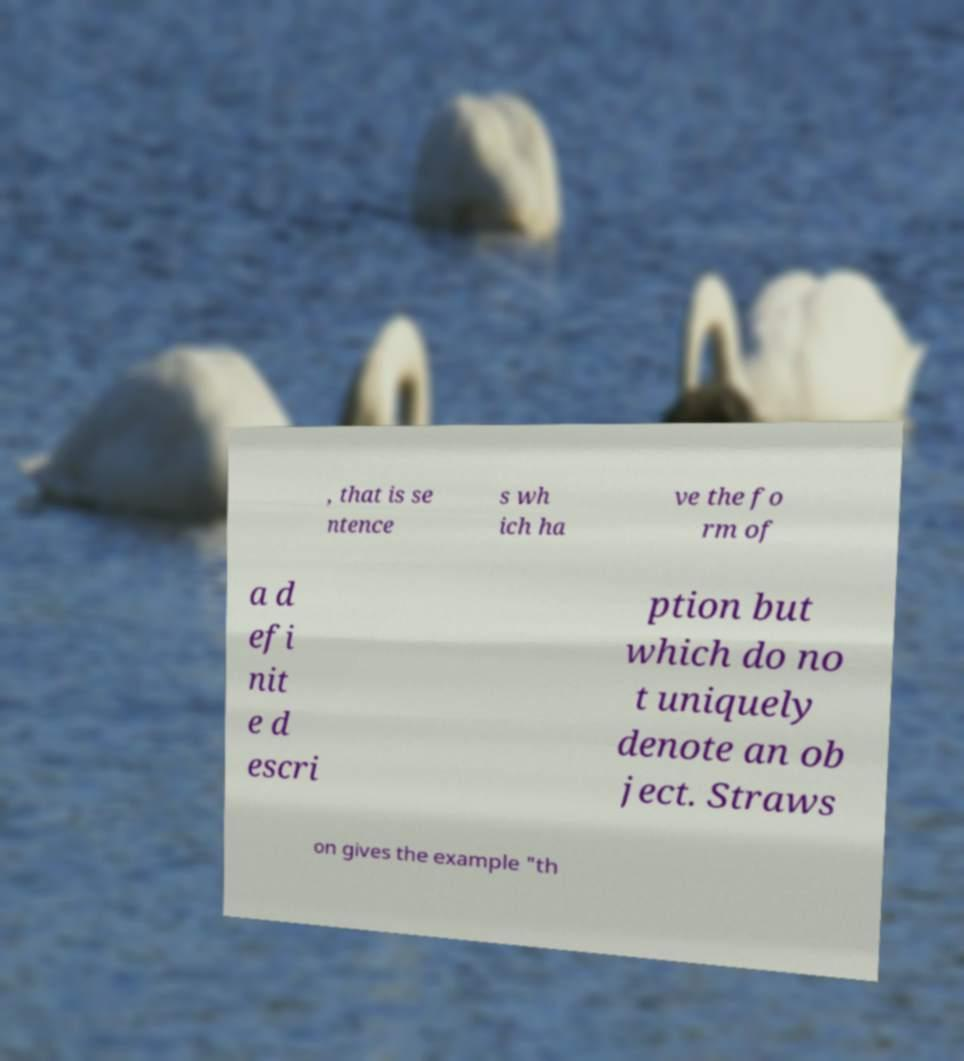Please identify and transcribe the text found in this image. , that is se ntence s wh ich ha ve the fo rm of a d efi nit e d escri ption but which do no t uniquely denote an ob ject. Straws on gives the example "th 